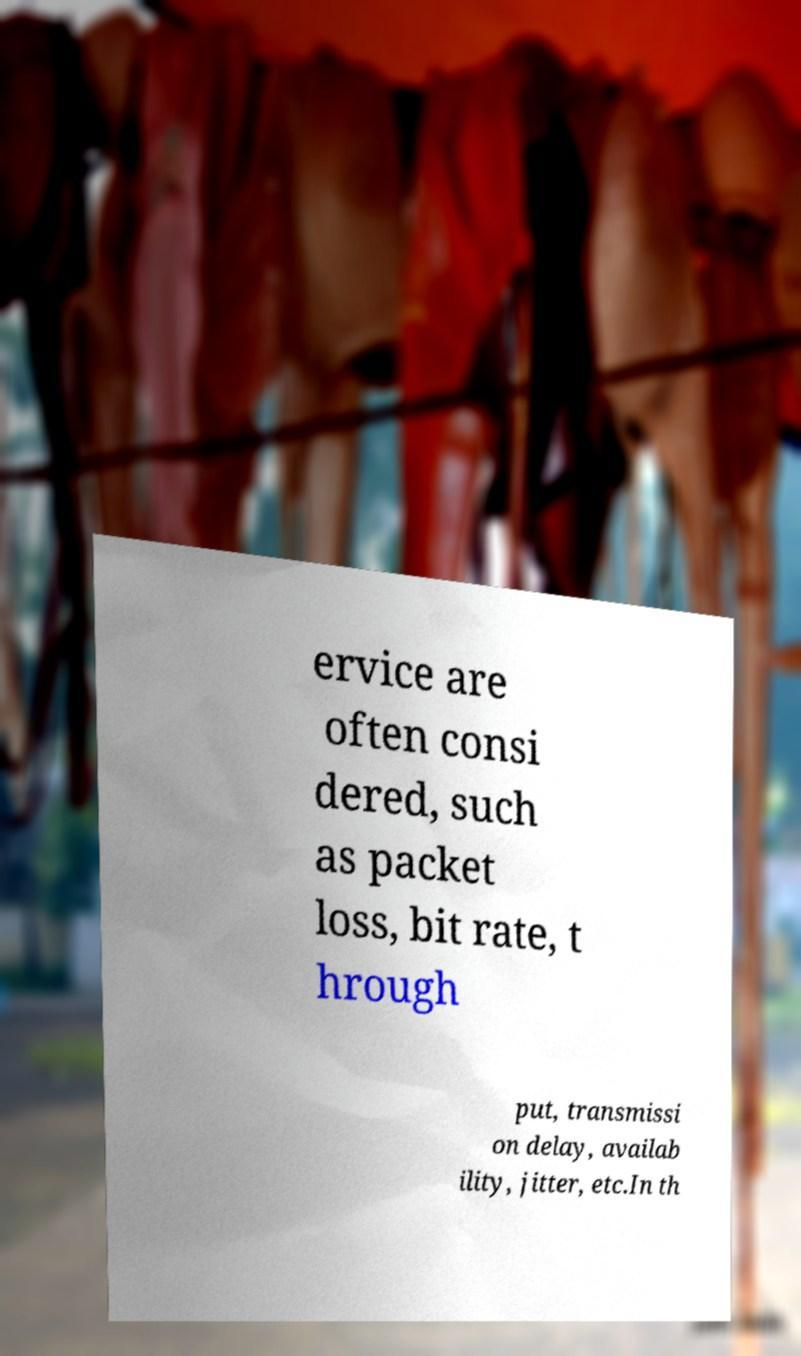I need the written content from this picture converted into text. Can you do that? ervice are often consi dered, such as packet loss, bit rate, t hrough put, transmissi on delay, availab ility, jitter, etc.In th 